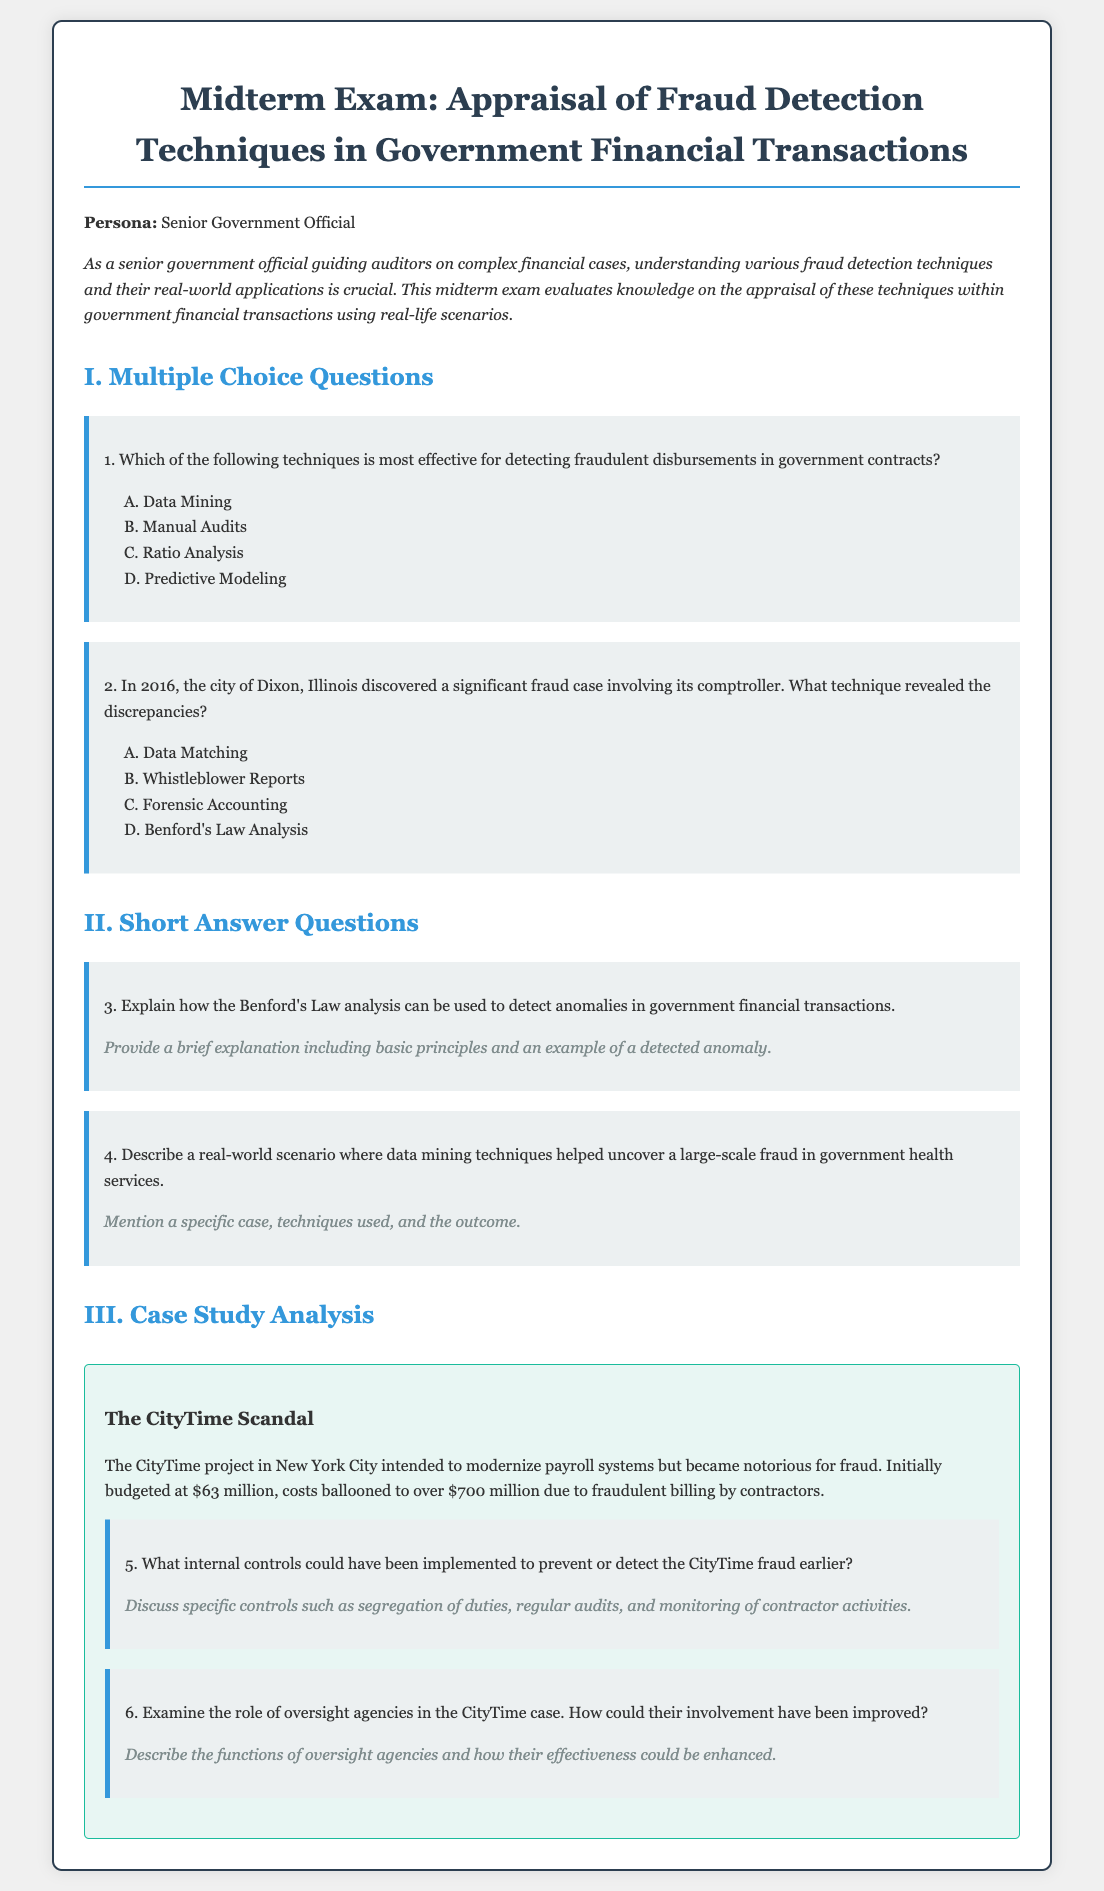What is the title of the exam? The title of the exam is stated in the header of the document as "Midterm Exam: Appraisal of Fraud Detection Techniques in Government Financial Transactions."
Answer: Midterm Exam: Appraisal of Fraud Detection Techniques in Government Financial Transactions What year did the City of Dixon fraud case occur? The document references the year when the significant fraud case in Dixon, Illinois was discovered, which is 2016.
Answer: 2016 Which fraud detection technique is most effective for detecting fraudulent disbursements according to question 1? The document presents options and indicates that the most effective technique for detecting fraudulent disbursements in government contracts is listed as option A.
Answer: Data Mining What was the initial budget for the CityTime project? The document states that the CityTime project was initially budgeted at $63 million.
Answer: $63 million What is mentioned as one of the techniques used to reveal discrepancies in the Dixon case? The options provided in the document show that one technique noted for discovering discrepancies in the Dixon case was forensic accounting.
Answer: Forensic Accounting What could have been implemented to prevent CityTime fraud earlier according to question 5? The question specifically asks for internal controls that could have been implemented to prevent or detect the CityTime fraud, including segregation of duties.
Answer: Segregation of duties How much did the costs of the CityTime project ultimately balloon to? The document indicates that the costs of the CityTime project escalated from the initial budget to over $700 million due to fraudulent billing.
Answer: Over $700 million What is the context for the short-answer questions in part II? The document specifies that part II contains questions that require examination of specific cases and techniques used in fraud detection.
Answer: Examination of specific cases and techniques used in fraud detection What color is used for the section title "Case Study Analysis"? The document shows that the section title "Case Study Analysis" is colored in a specific shade that corresponds with the format of the document.
Answer: Green 